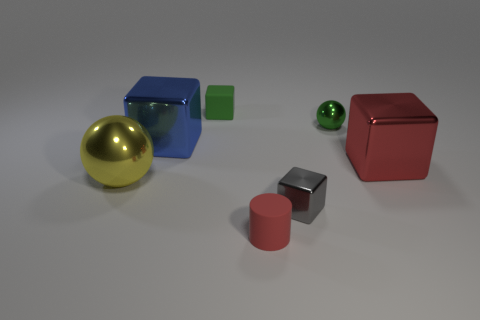There is a small object that is the same color as the small ball; what material is it?
Your answer should be very brief. Rubber. What number of tiny matte objects are behind the tiny cube in front of the matte block?
Provide a succinct answer. 1. Is the material of the large red cube the same as the big yellow ball?
Give a very brief answer. Yes. There is a small green thing that is right of the matte object that is in front of the small gray shiny block; how many gray objects are right of it?
Provide a succinct answer. 0. What color is the metallic sphere in front of the green sphere?
Your response must be concise. Yellow. There is a tiny red matte object that is to the left of the metallic sphere to the right of the big blue thing; what is its shape?
Provide a short and direct response. Cylinder. Do the tiny ball and the matte cube have the same color?
Keep it short and to the point. Yes. What number of cylinders are gray metallic objects or big red shiny things?
Your answer should be compact. 0. There is a thing that is both in front of the big yellow ball and right of the tiny matte cylinder; what material is it made of?
Your response must be concise. Metal. How many yellow metallic spheres are on the right side of the gray metal object?
Provide a succinct answer. 0. 